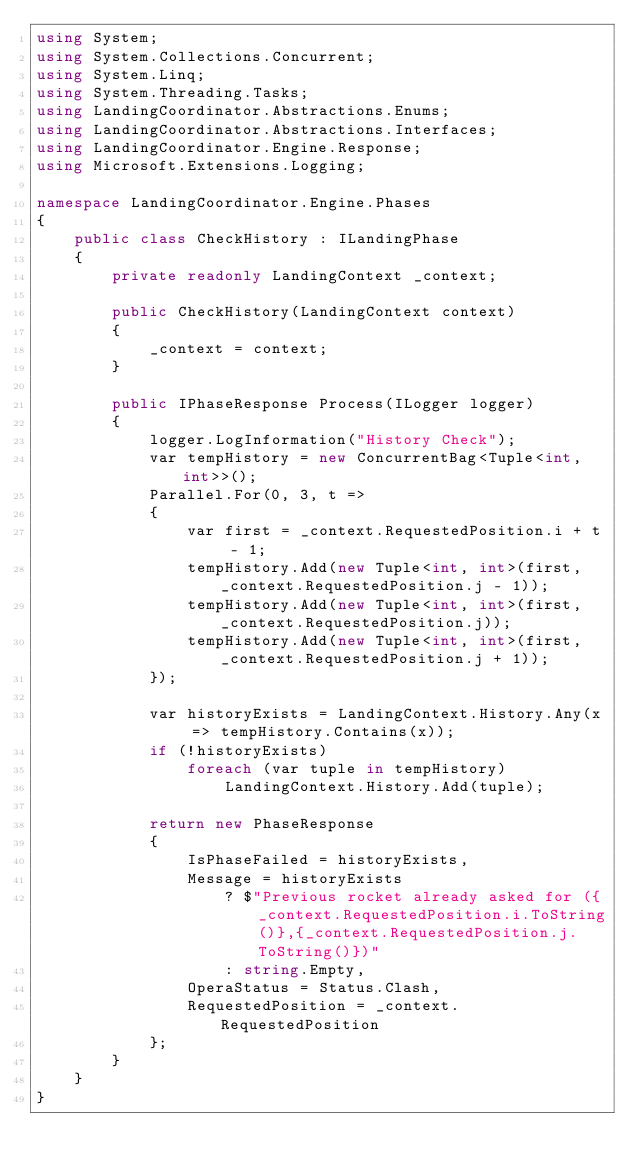Convert code to text. <code><loc_0><loc_0><loc_500><loc_500><_C#_>using System;
using System.Collections.Concurrent;
using System.Linq;
using System.Threading.Tasks;
using LandingCoordinator.Abstractions.Enums;
using LandingCoordinator.Abstractions.Interfaces;
using LandingCoordinator.Engine.Response;
using Microsoft.Extensions.Logging;

namespace LandingCoordinator.Engine.Phases
{
    public class CheckHistory : ILandingPhase
    {
        private readonly LandingContext _context;

        public CheckHistory(LandingContext context)
        {
            _context = context;
        }

        public IPhaseResponse Process(ILogger logger)
        {
            logger.LogInformation("History Check");
            var tempHistory = new ConcurrentBag<Tuple<int, int>>();
            Parallel.For(0, 3, t =>
            {
                var first = _context.RequestedPosition.i + t - 1;
                tempHistory.Add(new Tuple<int, int>(first, _context.RequestedPosition.j - 1));
                tempHistory.Add(new Tuple<int, int>(first, _context.RequestedPosition.j));
                tempHistory.Add(new Tuple<int, int>(first, _context.RequestedPosition.j + 1));
            });

            var historyExists = LandingContext.History.Any(x => tempHistory.Contains(x));
            if (!historyExists)
                foreach (var tuple in tempHistory)
                    LandingContext.History.Add(tuple);

            return new PhaseResponse
            {
                IsPhaseFailed = historyExists,
                Message = historyExists
                    ? $"Previous rocket already asked for ({_context.RequestedPosition.i.ToString()},{_context.RequestedPosition.j.ToString()})"
                    : string.Empty,
                OperaStatus = Status.Clash,
                RequestedPosition = _context.RequestedPosition
            };
        }
    }
}</code> 